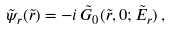Convert formula to latex. <formula><loc_0><loc_0><loc_500><loc_500>\tilde { \psi } _ { r } ( \tilde { r } ) = - i \, \tilde { G } _ { 0 } ( \tilde { r } , 0 ; \tilde { E } _ { r } ) \, ,</formula> 